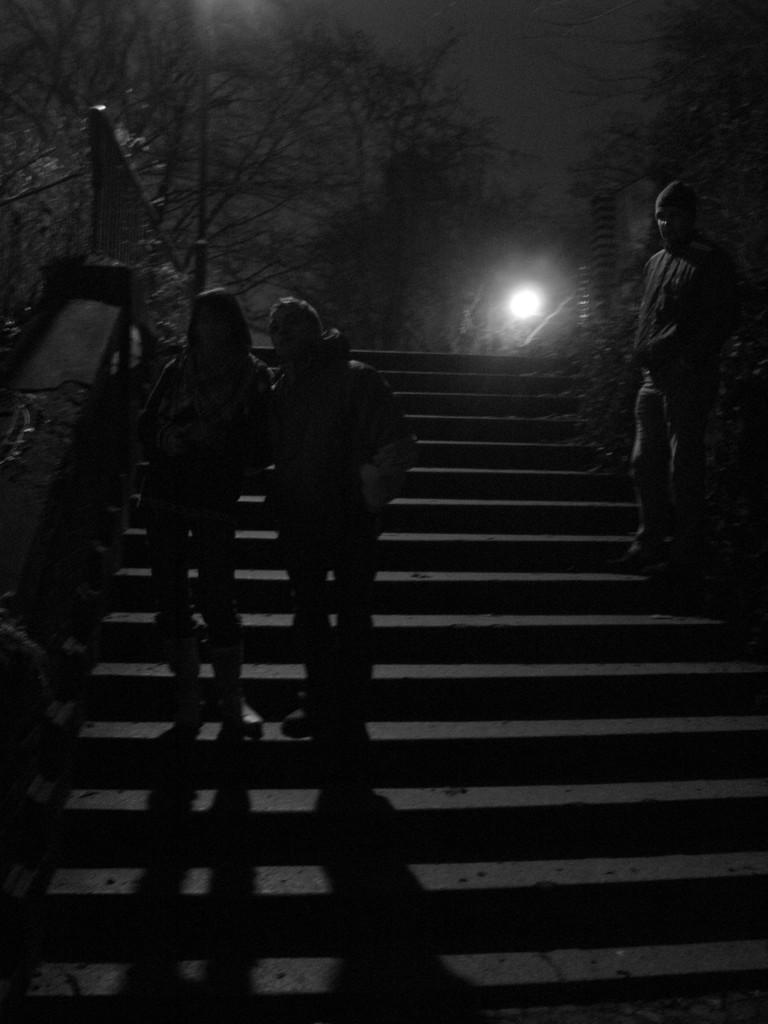How many people are present in the image? There are three persons standing in the image. What is located at the bottom of the image? There are steps at the bottom of the image. What can be seen in the background of the image? There is a light and trees in the background of the image. What feature is present on the left side of the image? There is a railing on the left side of the image. What type of underwear is the person on the right side of the image wearing? There is no information about the person's underwear in the image, as it is not visible or mentioned in the facts. 